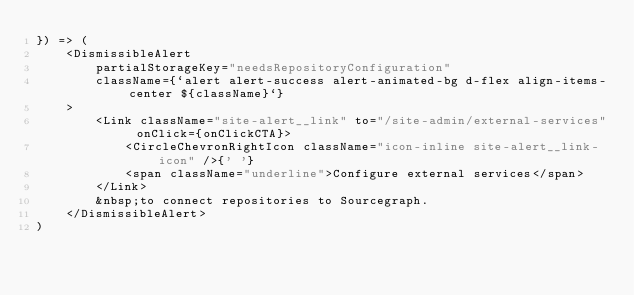<code> <loc_0><loc_0><loc_500><loc_500><_TypeScript_>}) => (
    <DismissibleAlert
        partialStorageKey="needsRepositoryConfiguration"
        className={`alert alert-success alert-animated-bg d-flex align-items-center ${className}`}
    >
        <Link className="site-alert__link" to="/site-admin/external-services" onClick={onClickCTA}>
            <CircleChevronRightIcon className="icon-inline site-alert__link-icon" />{' '}
            <span className="underline">Configure external services</span>
        </Link>
        &nbsp;to connect repositories to Sourcegraph.
    </DismissibleAlert>
)
</code> 